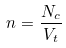Convert formula to latex. <formula><loc_0><loc_0><loc_500><loc_500>n = \frac { N _ { c } } { V _ { t } }</formula> 